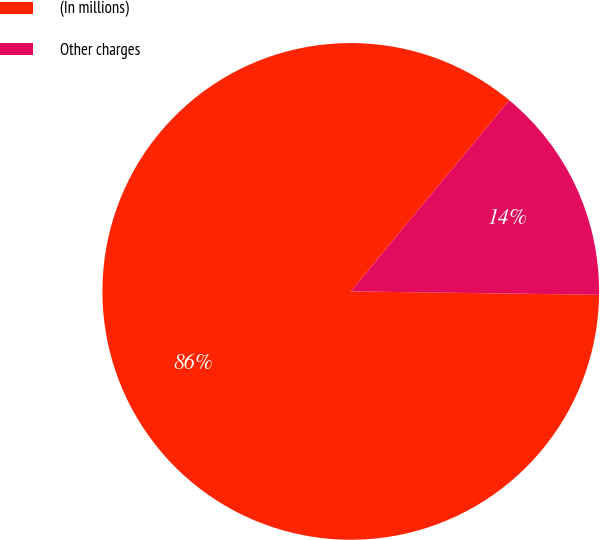<chart> <loc_0><loc_0><loc_500><loc_500><pie_chart><fcel>(In millions)<fcel>Other charges<nl><fcel>85.8%<fcel>14.2%<nl></chart> 